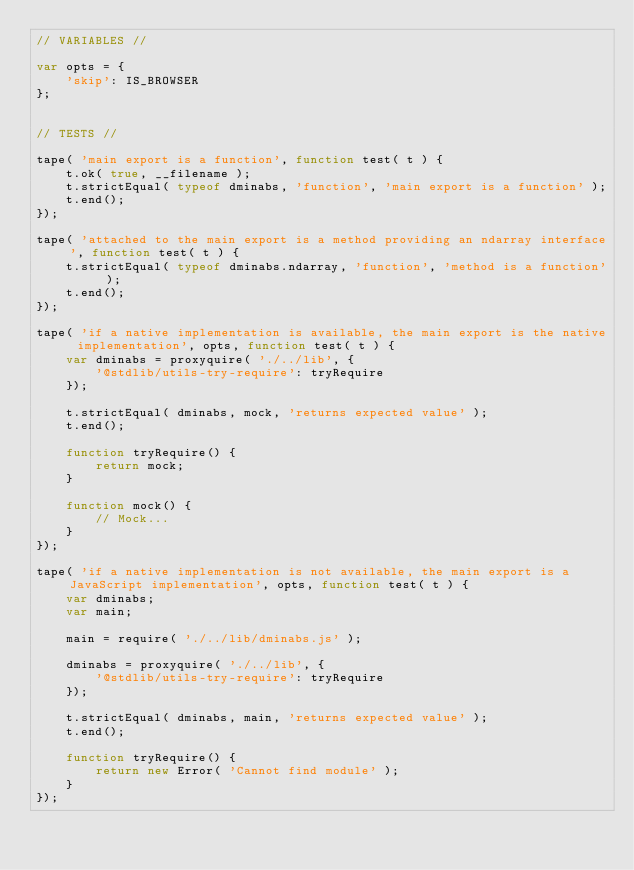<code> <loc_0><loc_0><loc_500><loc_500><_JavaScript_>// VARIABLES //

var opts = {
	'skip': IS_BROWSER
};


// TESTS //

tape( 'main export is a function', function test( t ) {
	t.ok( true, __filename );
	t.strictEqual( typeof dminabs, 'function', 'main export is a function' );
	t.end();
});

tape( 'attached to the main export is a method providing an ndarray interface', function test( t ) {
	t.strictEqual( typeof dminabs.ndarray, 'function', 'method is a function' );
	t.end();
});

tape( 'if a native implementation is available, the main export is the native implementation', opts, function test( t ) {
	var dminabs = proxyquire( './../lib', {
		'@stdlib/utils-try-require': tryRequire
	});

	t.strictEqual( dminabs, mock, 'returns expected value' );
	t.end();

	function tryRequire() {
		return mock;
	}

	function mock() {
		// Mock...
	}
});

tape( 'if a native implementation is not available, the main export is a JavaScript implementation', opts, function test( t ) {
	var dminabs;
	var main;

	main = require( './../lib/dminabs.js' );

	dminabs = proxyquire( './../lib', {
		'@stdlib/utils-try-require': tryRequire
	});

	t.strictEqual( dminabs, main, 'returns expected value' );
	t.end();

	function tryRequire() {
		return new Error( 'Cannot find module' );
	}
});
</code> 